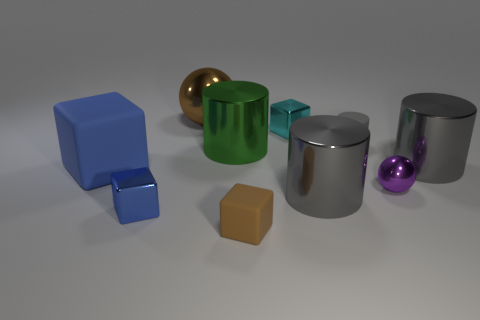There is a blue thing that is the same size as the green metallic cylinder; what is its material?
Offer a very short reply. Rubber. Are there any cyan shiny things of the same size as the green thing?
Ensure brevity in your answer.  No. There is a ball in front of the large blue cube; is it the same color as the matte cube on the right side of the green thing?
Offer a terse response. No. What number of matte things are big blue cubes or big balls?
Offer a very short reply. 1. There is a ball right of the brown thing behind the big green cylinder; how many tiny matte cubes are behind it?
Keep it short and to the point. 0. There is a blue cube that is the same material as the small gray cylinder; what is its size?
Your response must be concise. Large. What number of small shiny blocks are the same color as the large matte object?
Make the answer very short. 1. There is a metallic cylinder that is in front of the purple sphere; is it the same size as the tiny gray rubber object?
Give a very brief answer. No. There is a cube that is both in front of the big matte thing and left of the large brown object; what is its color?
Offer a very short reply. Blue. How many things are large blocks or large gray metal objects left of the small cylinder?
Your answer should be very brief. 2. 